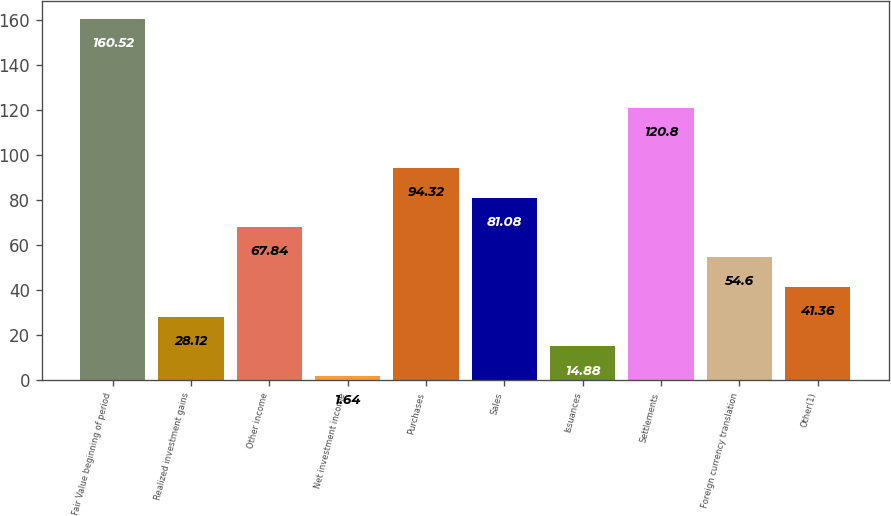Convert chart. <chart><loc_0><loc_0><loc_500><loc_500><bar_chart><fcel>Fair Value beginning of period<fcel>Realized investment gains<fcel>Other income<fcel>Net investment income<fcel>Purchases<fcel>Sales<fcel>Issuances<fcel>Settlements<fcel>Foreign currency translation<fcel>Other(1)<nl><fcel>160.52<fcel>28.12<fcel>67.84<fcel>1.64<fcel>94.32<fcel>81.08<fcel>14.88<fcel>120.8<fcel>54.6<fcel>41.36<nl></chart> 